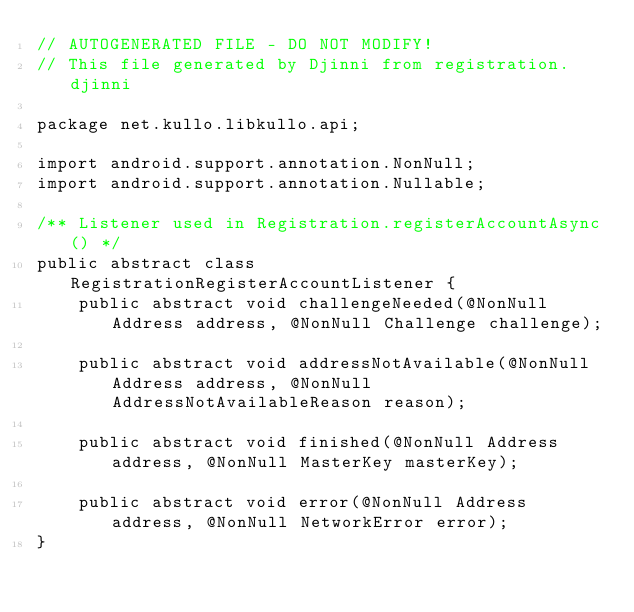<code> <loc_0><loc_0><loc_500><loc_500><_Java_>// AUTOGENERATED FILE - DO NOT MODIFY!
// This file generated by Djinni from registration.djinni

package net.kullo.libkullo.api;

import android.support.annotation.NonNull;
import android.support.annotation.Nullable;

/** Listener used in Registration.registerAccountAsync() */
public abstract class RegistrationRegisterAccountListener {
    public abstract void challengeNeeded(@NonNull Address address, @NonNull Challenge challenge);

    public abstract void addressNotAvailable(@NonNull Address address, @NonNull AddressNotAvailableReason reason);

    public abstract void finished(@NonNull Address address, @NonNull MasterKey masterKey);

    public abstract void error(@NonNull Address address, @NonNull NetworkError error);
}
</code> 